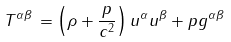<formula> <loc_0><loc_0><loc_500><loc_500>T ^ { \alpha \beta } \, = \left ( \rho + { \frac { p } { c ^ { 2 } } } \right ) u ^ { \alpha } u ^ { \beta } + p g ^ { \alpha \beta }</formula> 